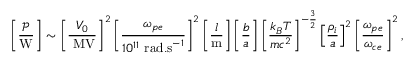<formula> <loc_0><loc_0><loc_500><loc_500>\left [ \frac { \mathcal { P } } { W } \right ] \sim \left [ \frac { V _ { 0 } } { M V } \right ] ^ { 2 } \left [ \frac { \omega _ { p e } } { 1 0 ^ { 1 1 } r a d . s ^ { - 1 } } \right ] ^ { 2 } \left [ \frac { l } { m } \right ] \left [ \frac { b } { a } \right ] \left [ \frac { k _ { B } T } { m c ^ { 2 } } \right ] ^ { - \frac { 3 } { 2 } } \left [ \frac { \rho _ { i } } { a } \right ] ^ { 2 } \left [ \frac { \omega _ { p e } } { \omega _ { c e } } \right ] ^ { 2 } ,</formula> 